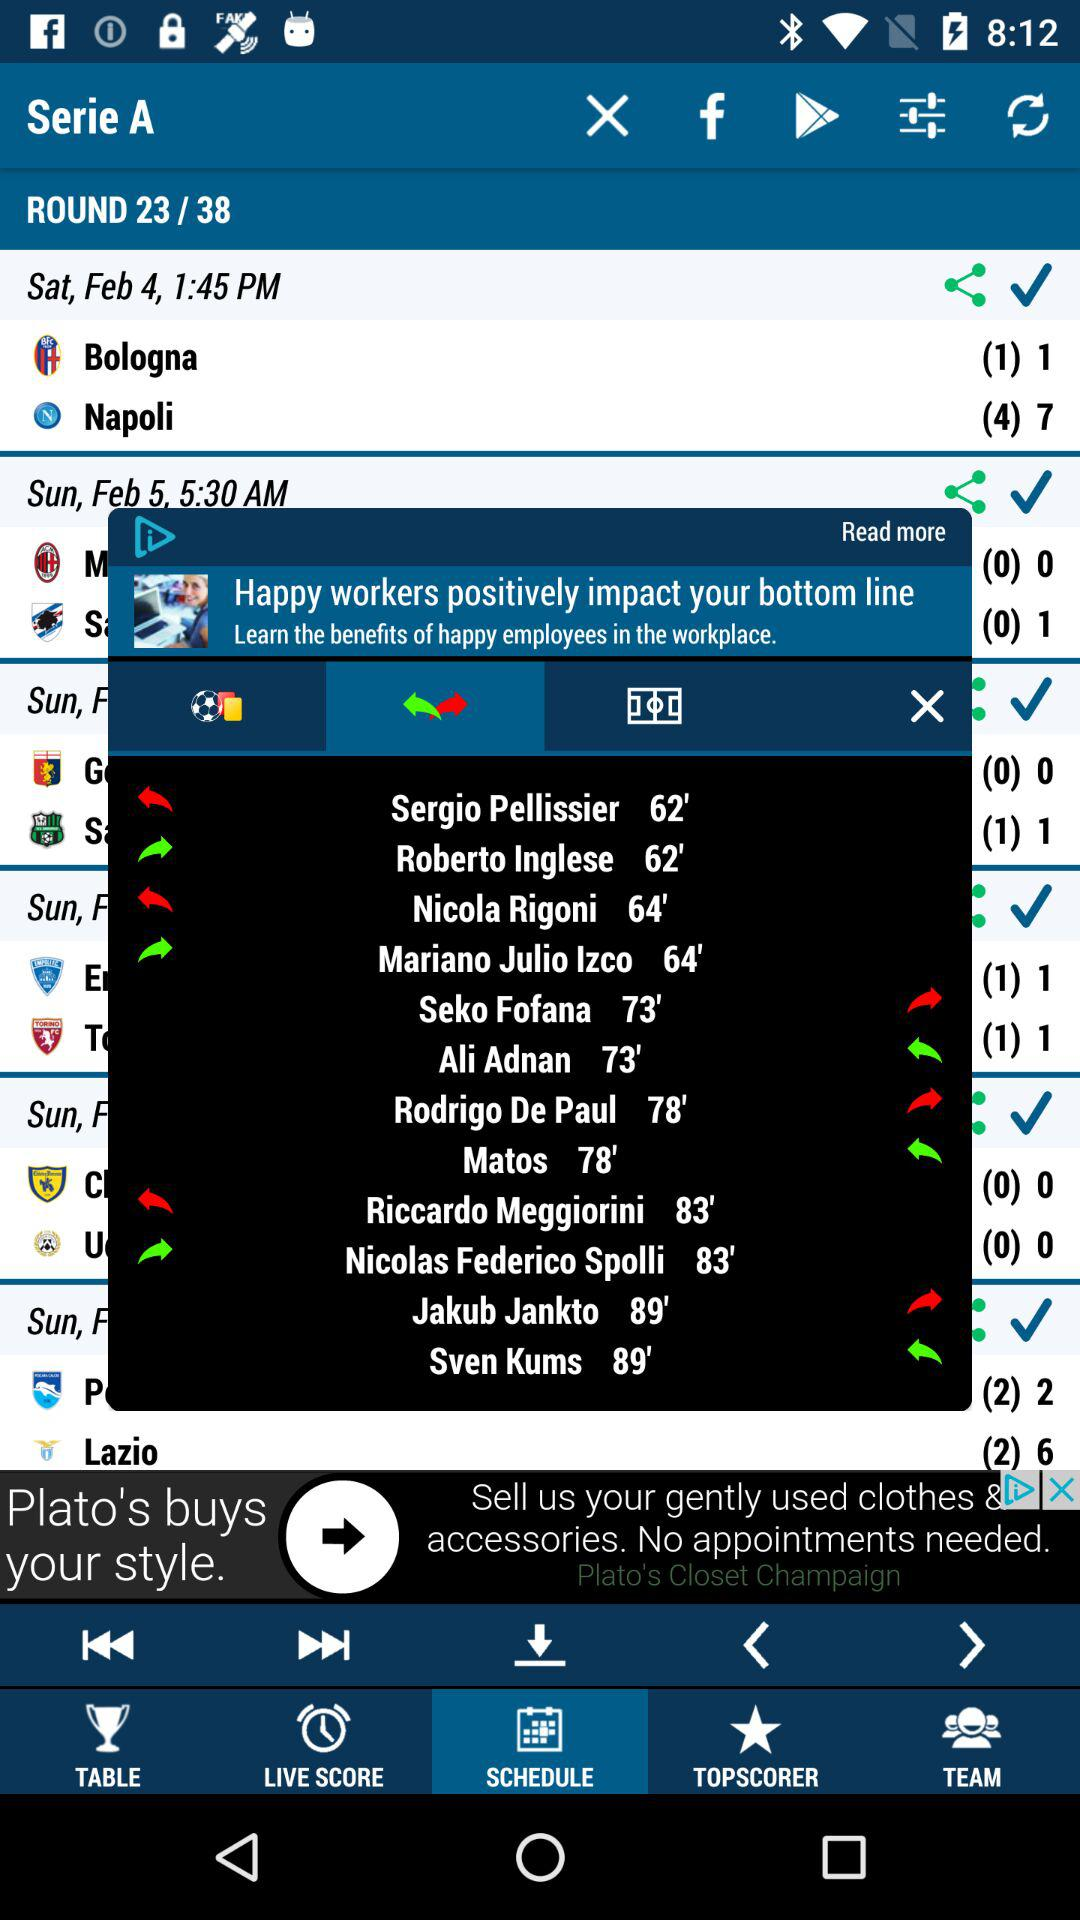At what time was the match between "Bologna" and "Napoli" played? The match between "Bologna" and "Napoli" was played at 1:45 PM. 